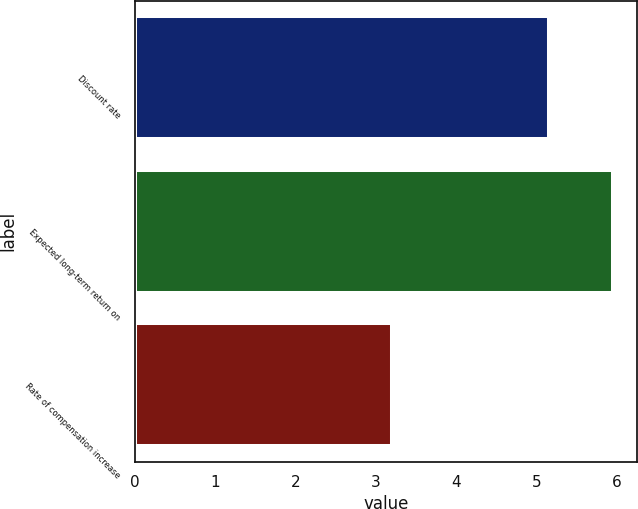<chart> <loc_0><loc_0><loc_500><loc_500><bar_chart><fcel>Discount rate<fcel>Expected long-term return on<fcel>Rate of compensation increase<nl><fcel>5.15<fcel>5.95<fcel>3.2<nl></chart> 